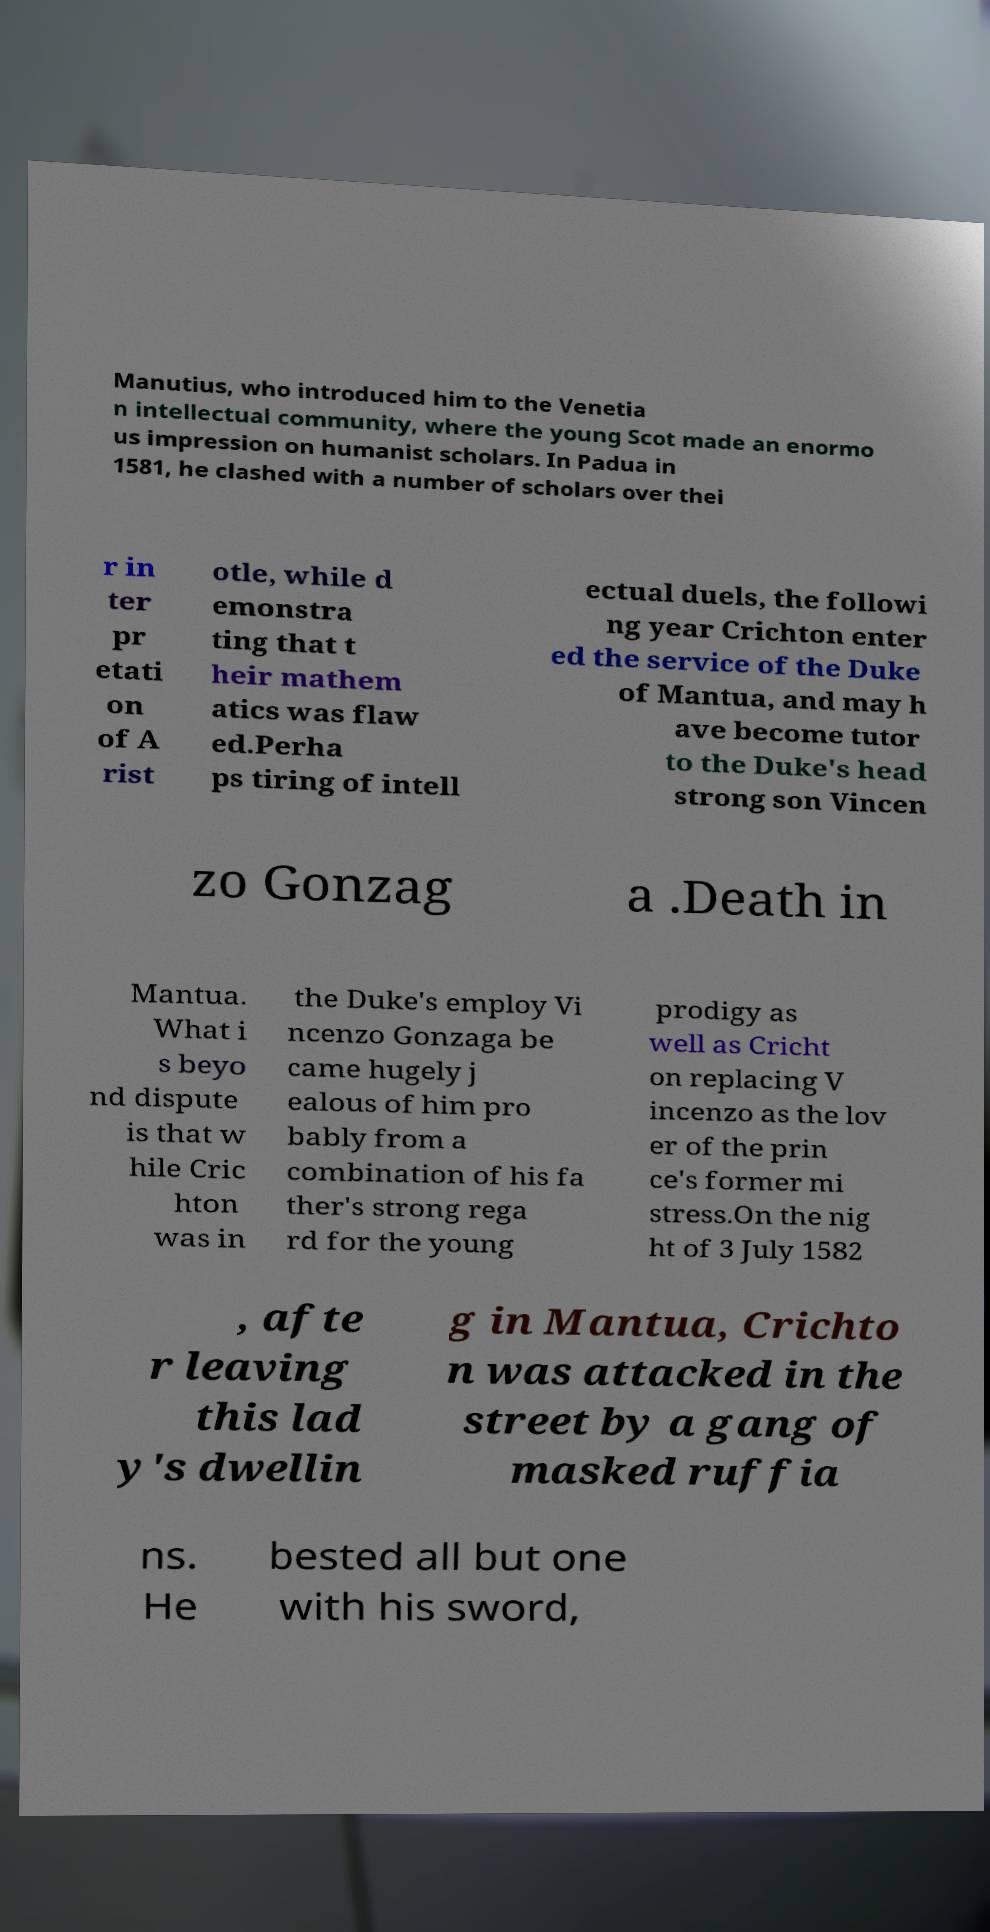For documentation purposes, I need the text within this image transcribed. Could you provide that? Manutius, who introduced him to the Venetia n intellectual community, where the young Scot made an enormo us impression on humanist scholars. In Padua in 1581, he clashed with a number of scholars over thei r in ter pr etati on of A rist otle, while d emonstra ting that t heir mathem atics was flaw ed.Perha ps tiring of intell ectual duels, the followi ng year Crichton enter ed the service of the Duke of Mantua, and may h ave become tutor to the Duke's head strong son Vincen zo Gonzag a .Death in Mantua. What i s beyo nd dispute is that w hile Cric hton was in the Duke's employ Vi ncenzo Gonzaga be came hugely j ealous of him pro bably from a combination of his fa ther's strong rega rd for the young prodigy as well as Cricht on replacing V incenzo as the lov er of the prin ce's former mi stress.On the nig ht of 3 July 1582 , afte r leaving this lad y's dwellin g in Mantua, Crichto n was attacked in the street by a gang of masked ruffia ns. He bested all but one with his sword, 